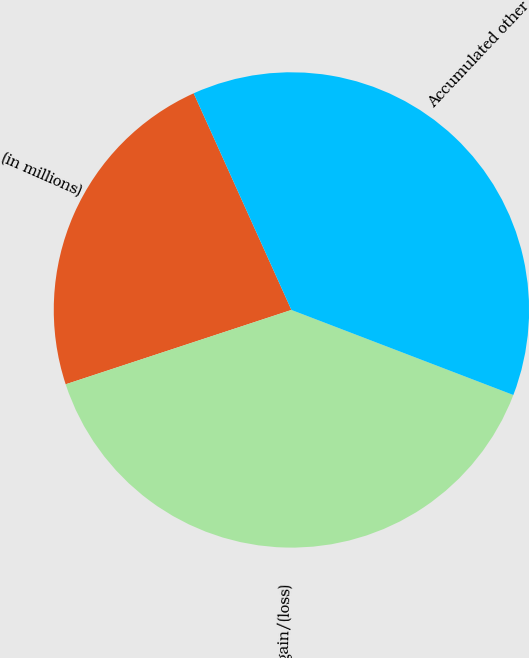<chart> <loc_0><loc_0><loc_500><loc_500><pie_chart><fcel>(in millions)<fcel>Net gain/(loss)<fcel>Accumulated other<nl><fcel>23.32%<fcel>39.11%<fcel>37.57%<nl></chart> 